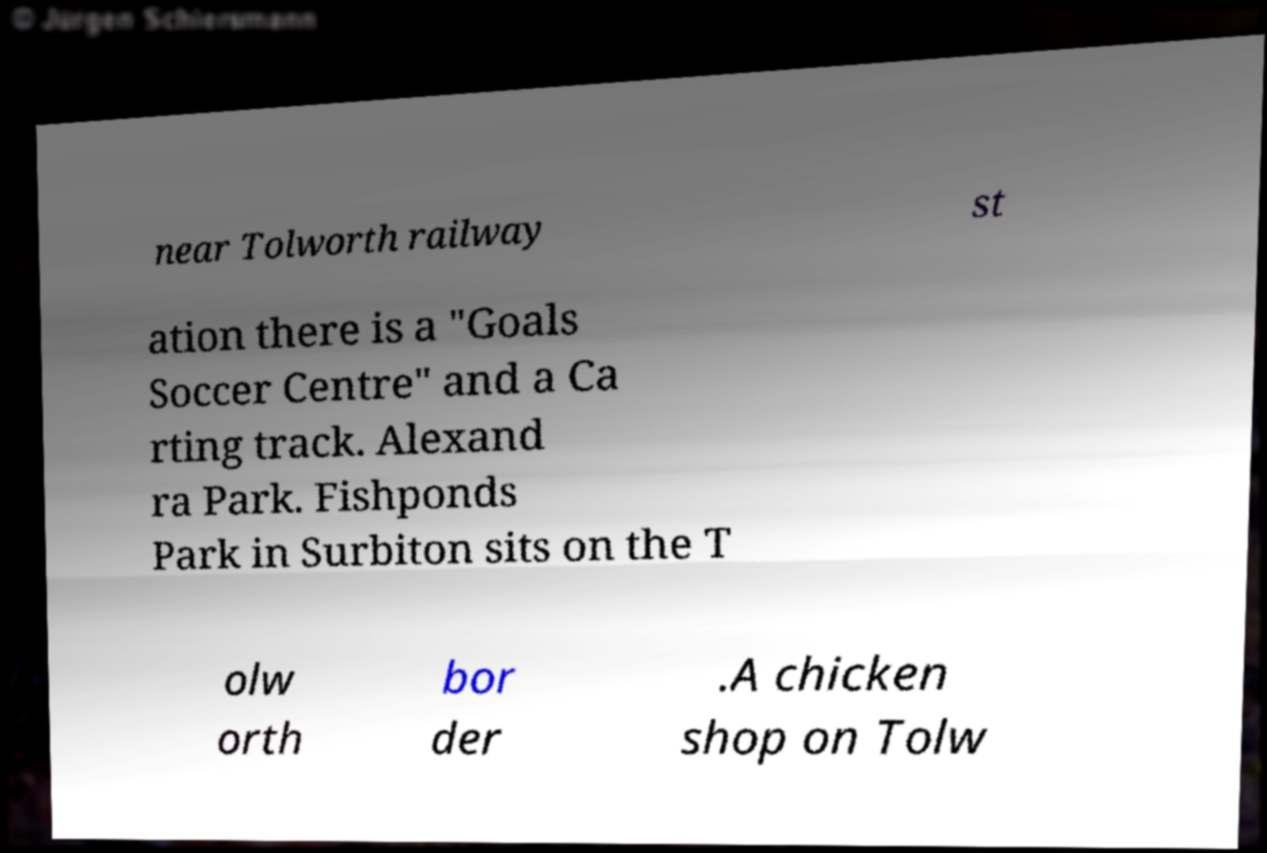Can you read and provide the text displayed in the image?This photo seems to have some interesting text. Can you extract and type it out for me? near Tolworth railway st ation there is a "Goals Soccer Centre" and a Ca rting track. Alexand ra Park. Fishponds Park in Surbiton sits on the T olw orth bor der .A chicken shop on Tolw 